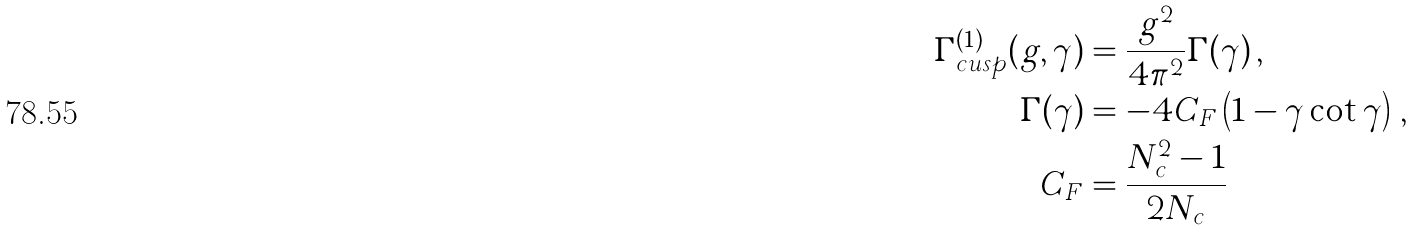Convert formula to latex. <formula><loc_0><loc_0><loc_500><loc_500>\Gamma _ { c u s p } ^ { ( 1 ) } ( g , \gamma ) & = \frac { g ^ { 2 } } { 4 \pi ^ { 2 } } \Gamma ( \gamma ) \, , \\ \Gamma ( \gamma ) & = - 4 C _ { F } \left ( 1 - \gamma \cot \gamma \right ) \, , \\ C _ { F } & = \frac { N _ { c } ^ { 2 } - 1 } { 2 N _ { c } } \,</formula> 